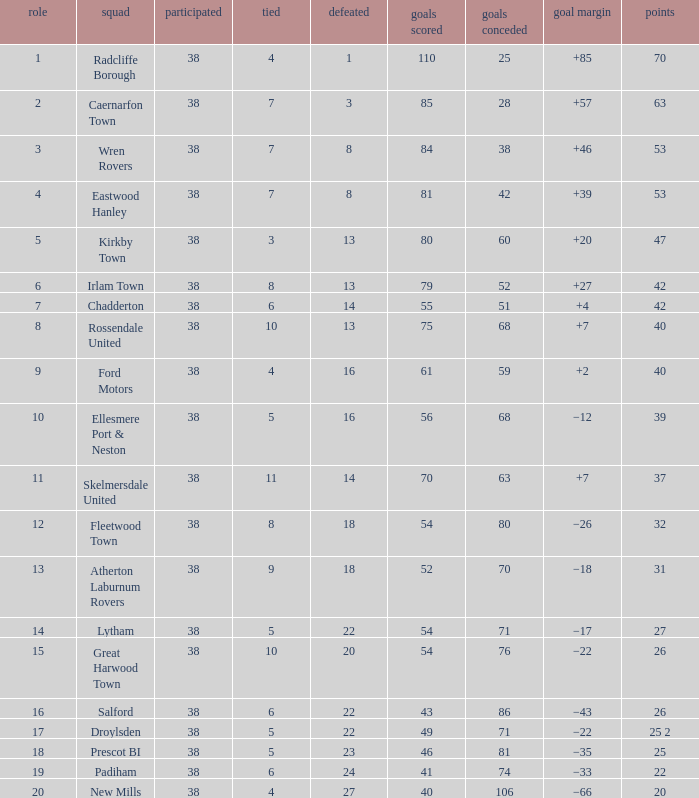How much Drawn has Goals Against larger than 74, and a Lost smaller than 20, and a Played larger than 38? 0.0. I'm looking to parse the entire table for insights. Could you assist me with that? {'header': ['role', 'squad', 'participated', 'tied', 'defeated', 'goals scored', 'goals conceded', 'goal margin', 'points'], 'rows': [['1', 'Radcliffe Borough', '38', '4', '1', '110', '25', '+85', '70'], ['2', 'Caernarfon Town', '38', '7', '3', '85', '28', '+57', '63'], ['3', 'Wren Rovers', '38', '7', '8', '84', '38', '+46', '53'], ['4', 'Eastwood Hanley', '38', '7', '8', '81', '42', '+39', '53'], ['5', 'Kirkby Town', '38', '3', '13', '80', '60', '+20', '47'], ['6', 'Irlam Town', '38', '8', '13', '79', '52', '+27', '42'], ['7', 'Chadderton', '38', '6', '14', '55', '51', '+4', '42'], ['8', 'Rossendale United', '38', '10', '13', '75', '68', '+7', '40'], ['9', 'Ford Motors', '38', '4', '16', '61', '59', '+2', '40'], ['10', 'Ellesmere Port & Neston', '38', '5', '16', '56', '68', '−12', '39'], ['11', 'Skelmersdale United', '38', '11', '14', '70', '63', '+7', '37'], ['12', 'Fleetwood Town', '38', '8', '18', '54', '80', '−26', '32'], ['13', 'Atherton Laburnum Rovers', '38', '9', '18', '52', '70', '−18', '31'], ['14', 'Lytham', '38', '5', '22', '54', '71', '−17', '27'], ['15', 'Great Harwood Town', '38', '10', '20', '54', '76', '−22', '26'], ['16', 'Salford', '38', '6', '22', '43', '86', '−43', '26'], ['17', 'Droylsden', '38', '5', '22', '49', '71', '−22', '25 2'], ['18', 'Prescot BI', '38', '5', '23', '46', '81', '−35', '25'], ['19', 'Padiham', '38', '6', '24', '41', '74', '−33', '22'], ['20', 'New Mills', '38', '4', '27', '40', '106', '−66', '20']]} 